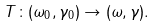Convert formula to latex. <formula><loc_0><loc_0><loc_500><loc_500>T \colon ( \omega _ { 0 } , \gamma _ { 0 } ) \rightarrow ( \omega , \gamma ) .</formula> 